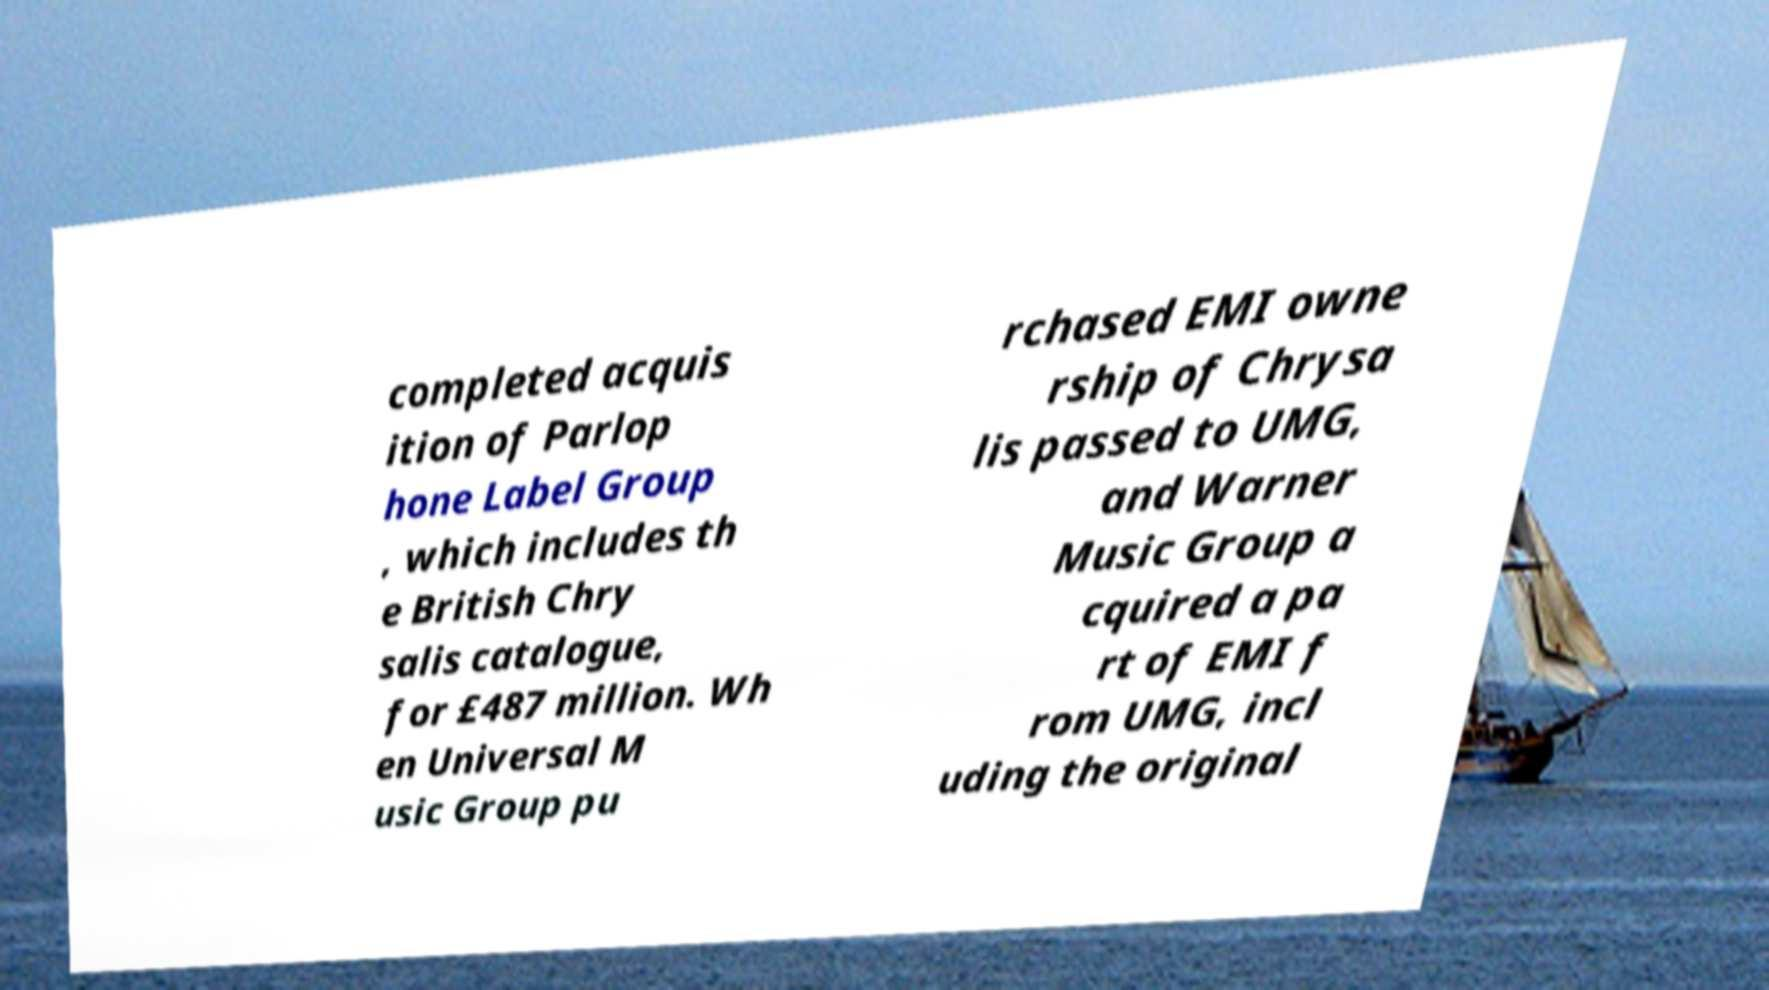Can you accurately transcribe the text from the provided image for me? completed acquis ition of Parlop hone Label Group , which includes th e British Chry salis catalogue, for £487 million. Wh en Universal M usic Group pu rchased EMI owne rship of Chrysa lis passed to UMG, and Warner Music Group a cquired a pa rt of EMI f rom UMG, incl uding the original 